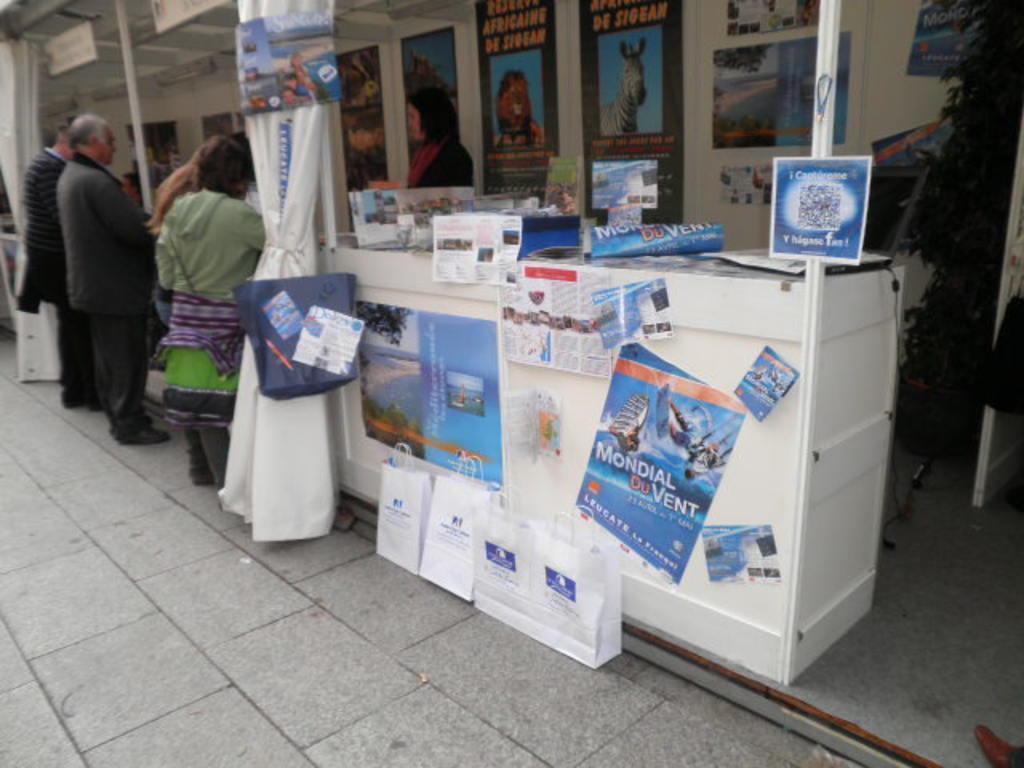How would you summarize this image in a sentence or two? There are few people standing. I can see the curtains hanging. These are the bags, which are placed on the floor. I can see the posts, which are attached to the table. This looks like a tree. I can see few other posters, which are attached to the wall. I think these are the name boards, which are hanging. 